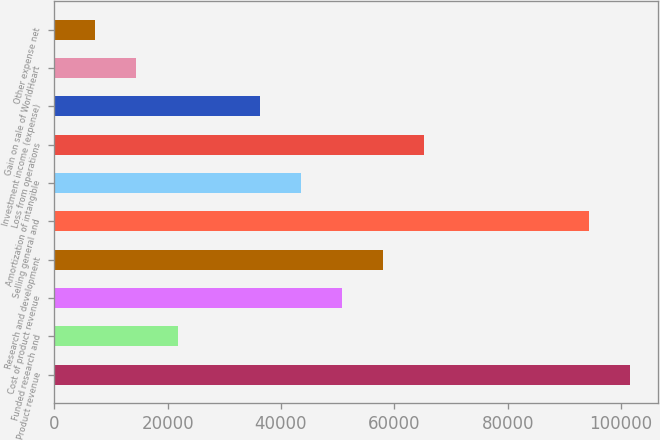Convert chart to OTSL. <chart><loc_0><loc_0><loc_500><loc_500><bar_chart><fcel>Product revenue<fcel>Funded research and<fcel>Cost of product revenue<fcel>Research and development<fcel>Selling general and<fcel>Amortization of intangible<fcel>Loss from operations<fcel>Investment income (expense)<fcel>Gain on sale of WorldHeart<fcel>Other expense net<nl><fcel>101516<fcel>21754.2<fcel>50758.7<fcel>58009.8<fcel>94265.3<fcel>43507.6<fcel>65260.9<fcel>36256.5<fcel>14503.1<fcel>7252.02<nl></chart> 